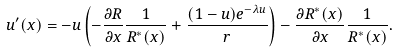<formula> <loc_0><loc_0><loc_500><loc_500>u ^ { \prime } ( x ) = - u \left ( - \frac { \partial R } { \partial x } \frac { 1 } { R ^ { * } ( x ) } + \frac { ( 1 - u ) e ^ { - \lambda u } } { r } \right ) - \frac { \partial R ^ { * } ( x ) } { \partial x } \frac { 1 } { R ^ { * } ( x ) } .</formula> 